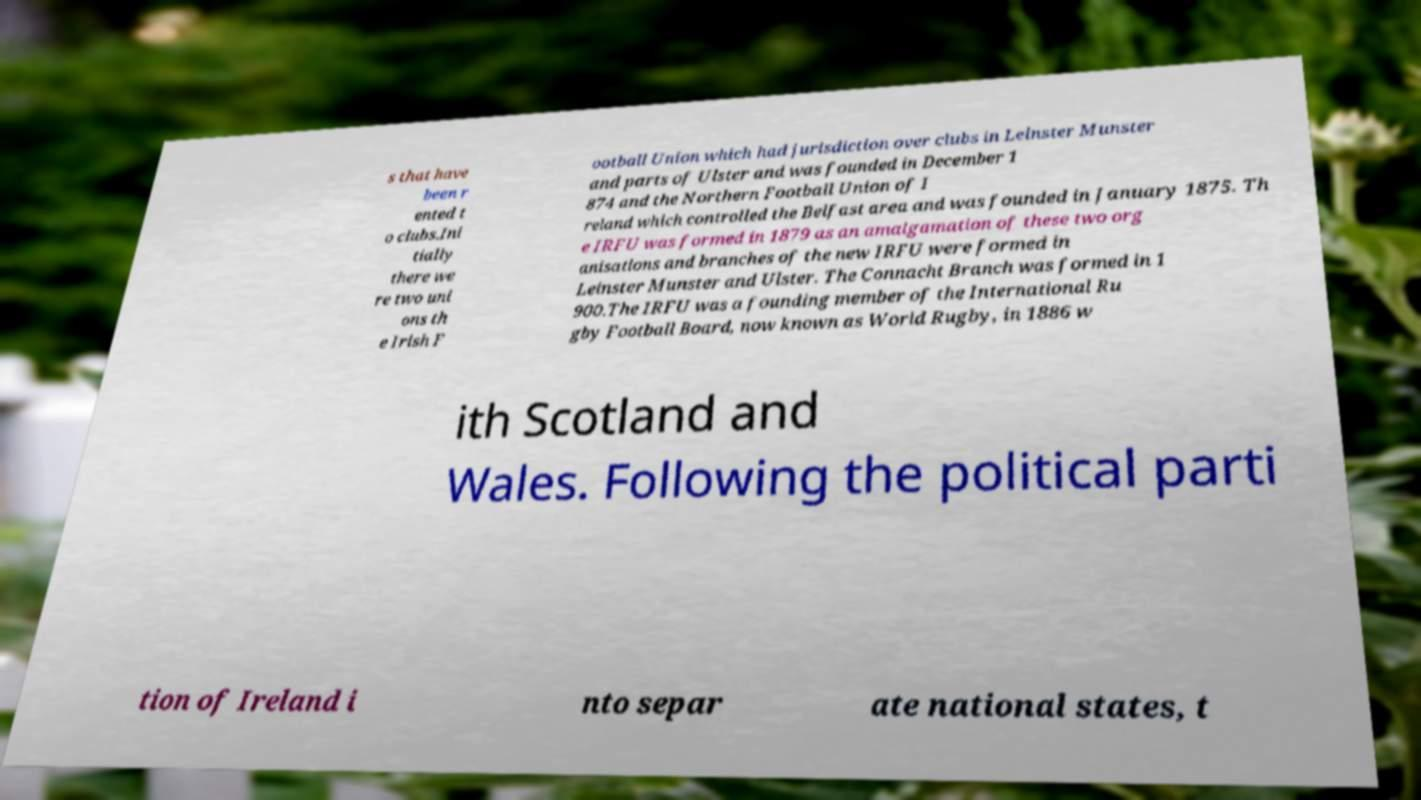Can you accurately transcribe the text from the provided image for me? s that have been r ented t o clubs.Ini tially there we re two uni ons th e Irish F ootball Union which had jurisdiction over clubs in Leinster Munster and parts of Ulster and was founded in December 1 874 and the Northern Football Union of I reland which controlled the Belfast area and was founded in January 1875. Th e IRFU was formed in 1879 as an amalgamation of these two org anisations and branches of the new IRFU were formed in Leinster Munster and Ulster. The Connacht Branch was formed in 1 900.The IRFU was a founding member of the International Ru gby Football Board, now known as World Rugby, in 1886 w ith Scotland and Wales. Following the political parti tion of Ireland i nto separ ate national states, t 